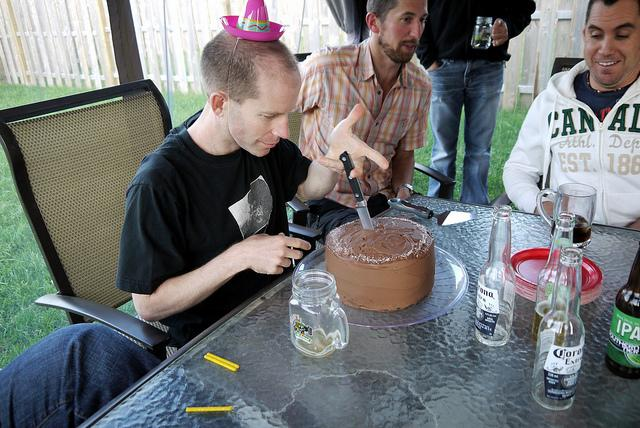What is in the cake?

Choices:
A) fork
B) knife
C) babys finger
D) spatula knife 